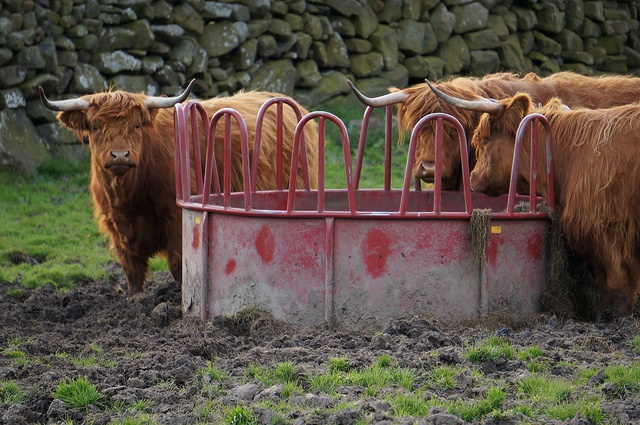Describe the objects in this image and their specific colors. I can see cow in black, maroon, and brown tones, cow in black, maroon, brown, and gray tones, and cow in black, gray, maroon, and brown tones in this image. 